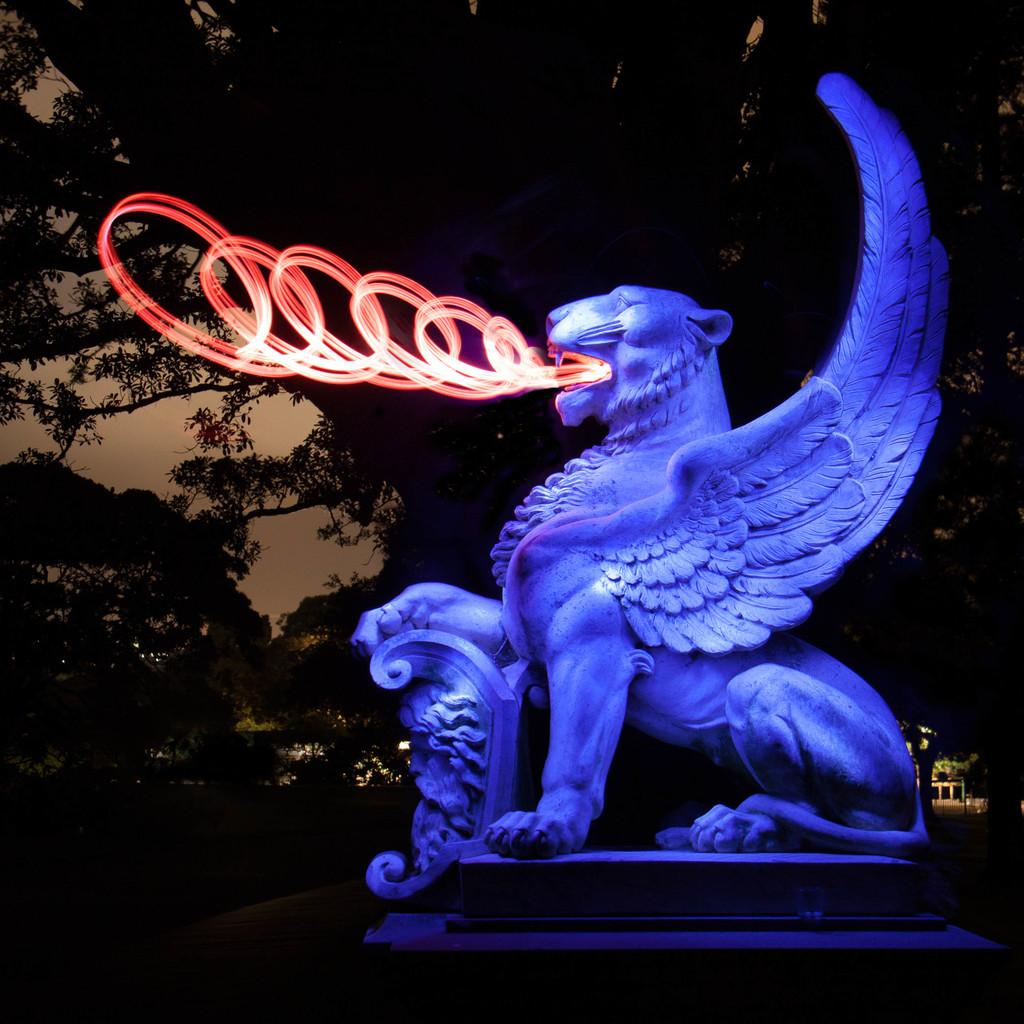What is the main subject in the image? There is a statue in the image. What can be seen in the background of the image? There are trees and the sky visible in the background of the image. What type of disease is affecting the statue in the image? There is no indication of any disease affecting the statue in the image. 